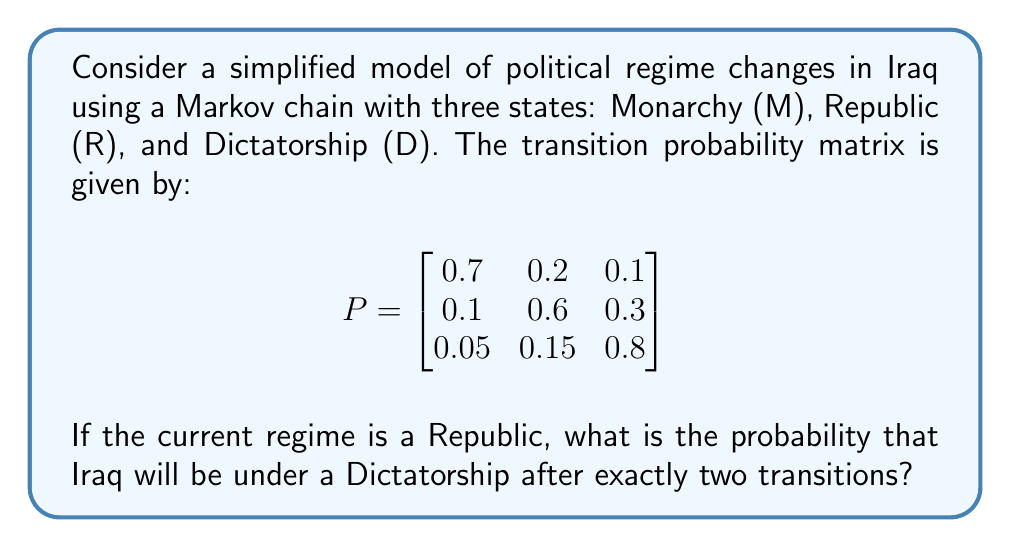Help me with this question. To solve this problem, we need to use the properties of Markov chains and matrix multiplication. Let's approach this step-by-step:

1) The initial state vector for a Republic is:
   $$v_0 = \begin{bmatrix} 0 & 1 & 0 \end{bmatrix}$$

2) We need to calculate the two-step transition probability matrix, which is $P^2$:

   $$P^2 = P \times P = \begin{bmatrix}
   0.7 & 0.2 & 0.1 \\
   0.1 & 0.6 & 0.3 \\
   0.05 & 0.15 & 0.8
   \end{bmatrix} \times 
   \begin{bmatrix}
   0.7 & 0.2 & 0.1 \\
   0.1 & 0.6 & 0.3 \\
   0.05 & 0.15 & 0.8
   \end{bmatrix}$$

3) Performing the matrix multiplication:

   $$P^2 = \begin{bmatrix}
   0.52 & 0.31 & 0.17 \\
   0.175 & 0.45 & 0.375 \\
   0.0875 & 0.2475 & 0.665
   \end{bmatrix}$$

4) The probability of transitioning from Republic (R) to Dictatorship (D) in two steps is the element in the second row, third column of $P^2$, which is 0.375.

This result indicates that if Iraq starts in a Republican regime, there is a 37.5% chance it will be under a Dictatorship after exactly two regime changes, according to this simplified model.
Answer: 0.375 